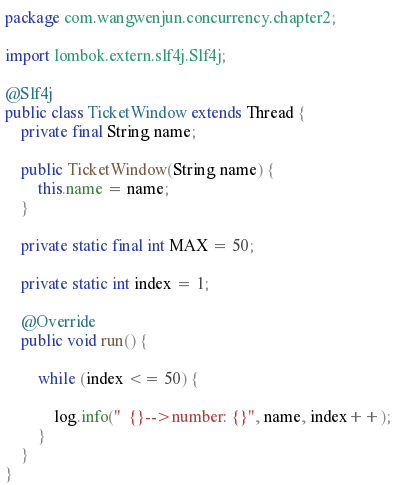Convert code to text. <code><loc_0><loc_0><loc_500><loc_500><_Java_>package com.wangwenjun.concurrency.chapter2;

import lombok.extern.slf4j.Slf4j;

@Slf4j
public class TicketWindow extends Thread {
	private final String name;

	public TicketWindow(String name) {
		this.name = name;
	}

	private static final int MAX = 50;

	private static int index = 1;

	@Override
	public void run() {

		while (index <= 50) {

			log.info("  {}-->number: {}", name, index++);
		}
	}
}
</code> 